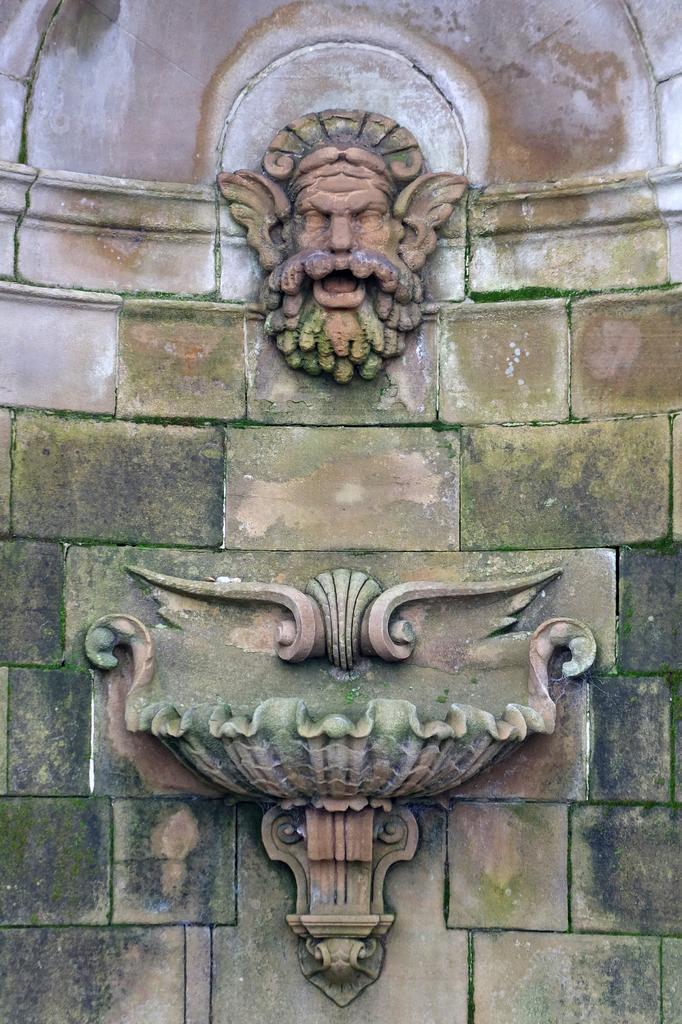Describe this image in one or two sentences. Here we can see stone carving and statue on a wall. 